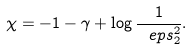Convert formula to latex. <formula><loc_0><loc_0><loc_500><loc_500>\chi = - 1 - \gamma + \log \frac { 1 } { \ e p s ^ { 2 } _ { 2 } } .</formula> 